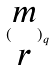<formula> <loc_0><loc_0><loc_500><loc_500>( \begin{matrix} m \\ r \end{matrix} ) _ { q }</formula> 